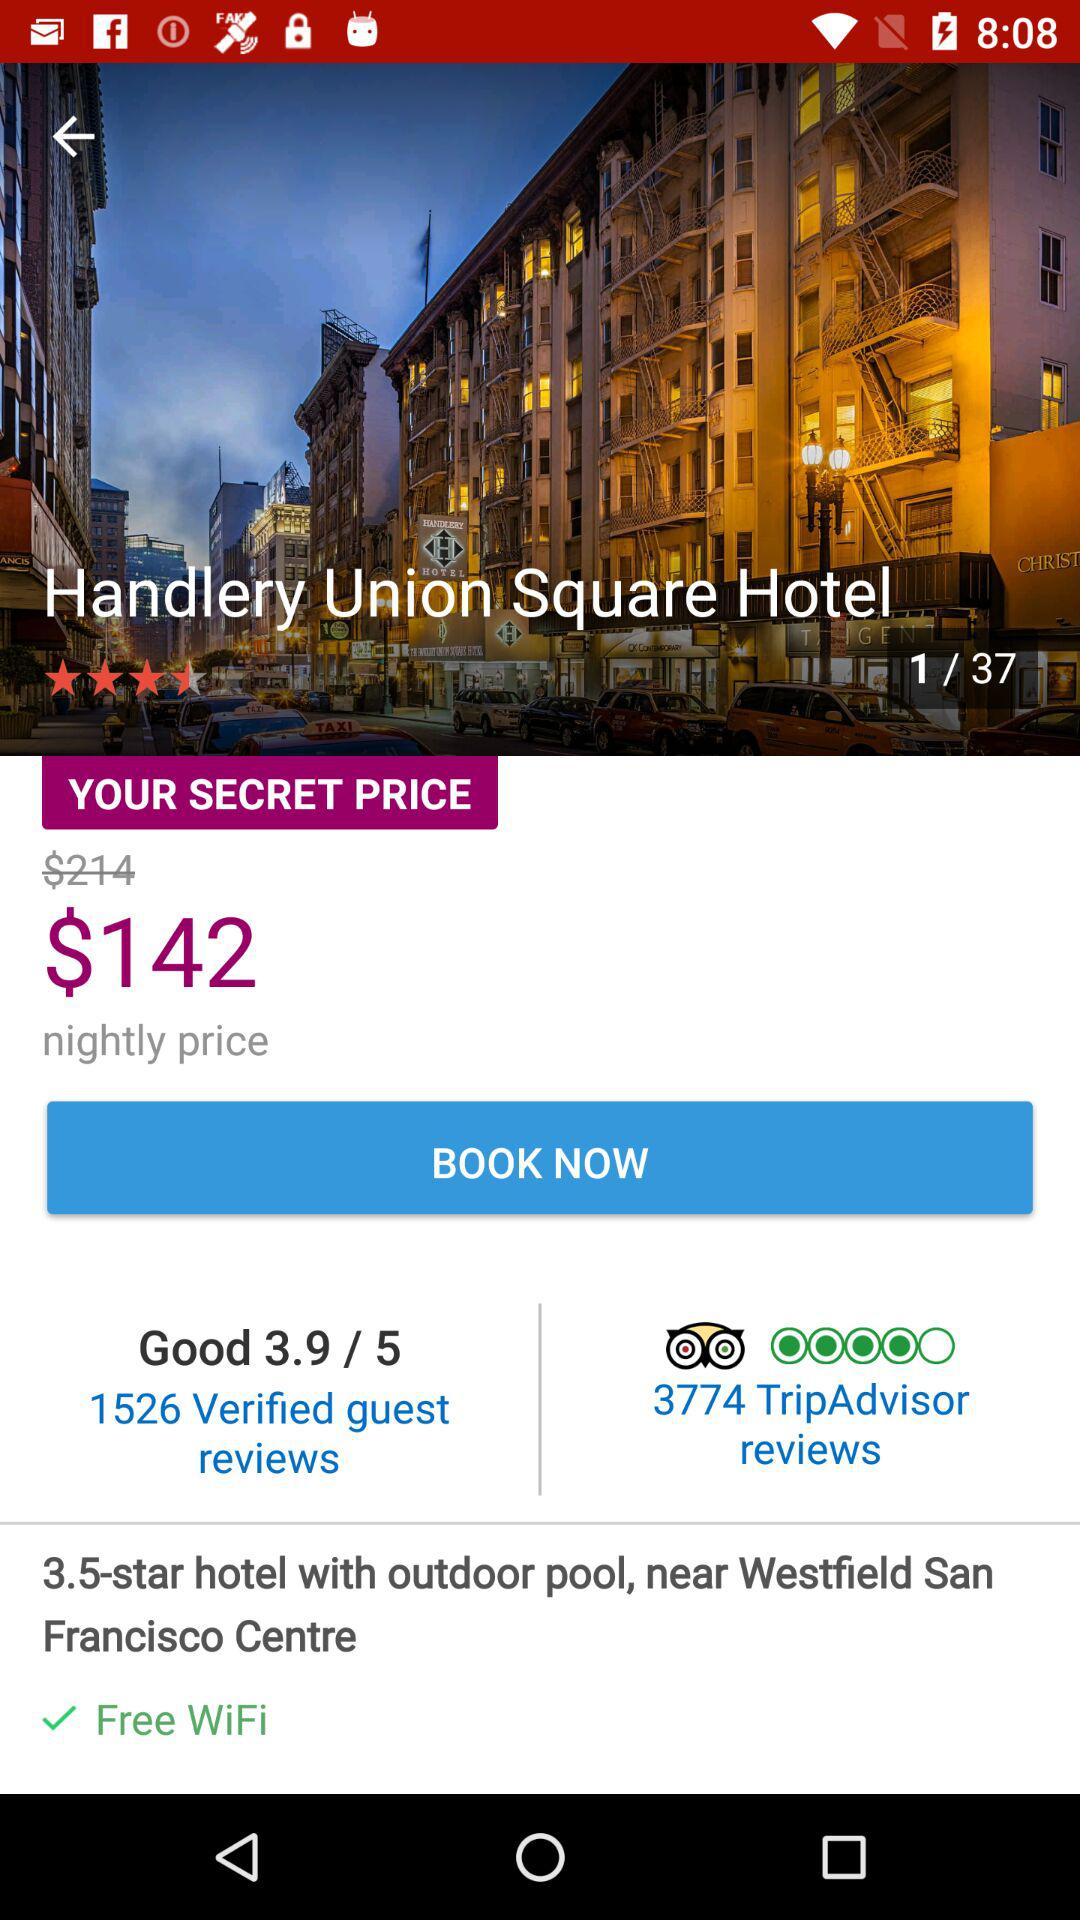How many "TripAdvisor" reviews are there? There are 3774 "TripAdvisor" reviews. 